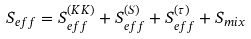<formula> <loc_0><loc_0><loc_500><loc_500>S _ { e f f } = S _ { e f f } ^ { ( K K ) } + S _ { e f f } ^ { ( S ) } + S _ { e f f } ^ { ( \tau ) } + S _ { m i x }</formula> 